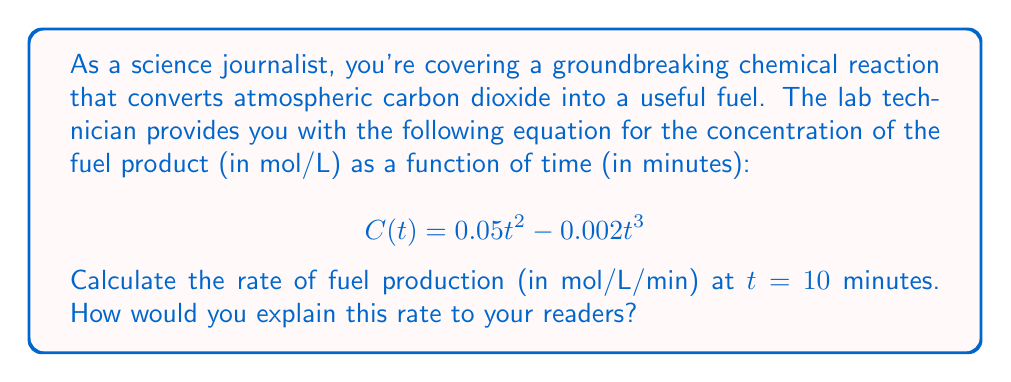What is the answer to this math problem? To find the rate of fuel production at a specific time, we need to calculate the derivative of the concentration function C(t) with respect to time and evaluate it at t = 10 minutes. Here's how we can do this step-by-step:

1) First, let's find the derivative of C(t):
   $$\frac{dC}{dt} = \frac{d}{dt}(0.05t^2 - 0.002t^3)$$

2) Using the power rule of differentiation:
   $$\frac{dC}{dt} = 0.05 \cdot 2t - 0.002 \cdot 3t^2$$
   $$\frac{dC}{dt} = 0.1t - 0.006t^2$$

3) This derivative represents the instantaneous rate of change of the fuel concentration, or the rate of fuel production.

4) To find the rate at t = 10 minutes, we substitute t = 10 into our derivative:
   $$\frac{dC}{dt}\bigg|_{t=10} = 0.1(10) - 0.006(10)^2$$
   $$= 1 - 0.6 = 0.4\text{ mol/L/min}$$

5) For the science journalism aspect, we can interpret this result as follows:
   At the 10-minute mark, the fuel is being produced at a rate of 0.4 moles per liter per minute. This means that if the reaction were to continue at this exact rate for one more minute, the concentration of the fuel would increase by 0.4 mol/L.
Answer: 0.4 mol/L/min 